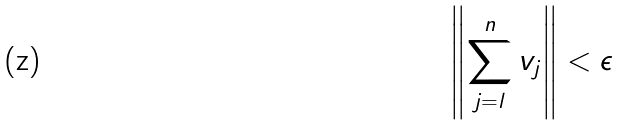<formula> <loc_0><loc_0><loc_500><loc_500>\left \| \sum _ { j = l } ^ { n } v _ { j } \right \| < \epsilon</formula> 